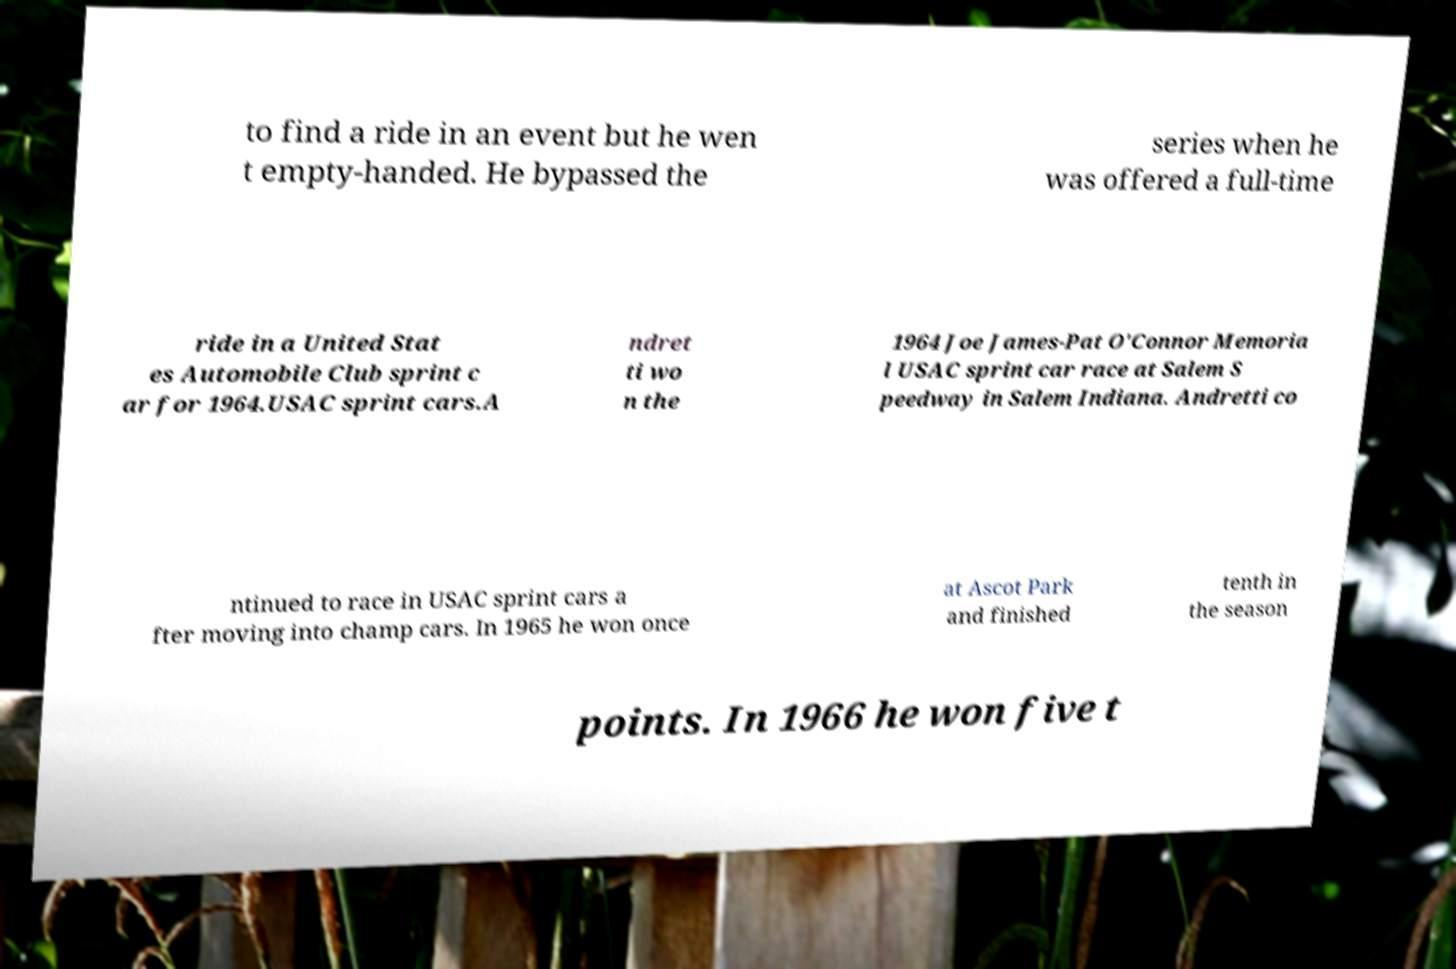What messages or text are displayed in this image? I need them in a readable, typed format. to find a ride in an event but he wen t empty-handed. He bypassed the series when he was offered a full-time ride in a United Stat es Automobile Club sprint c ar for 1964.USAC sprint cars.A ndret ti wo n the 1964 Joe James-Pat O'Connor Memoria l USAC sprint car race at Salem S peedway in Salem Indiana. Andretti co ntinued to race in USAC sprint cars a fter moving into champ cars. In 1965 he won once at Ascot Park and finished tenth in the season points. In 1966 he won five t 